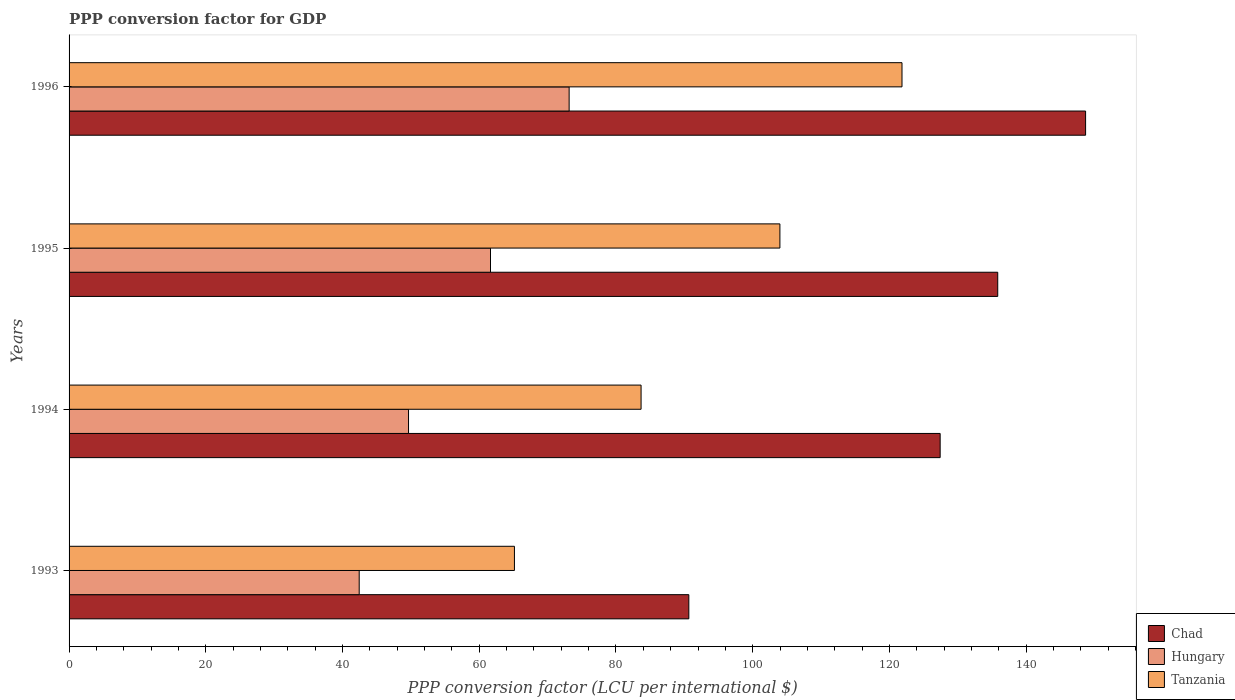How many different coloured bars are there?
Offer a very short reply. 3. How many groups of bars are there?
Ensure brevity in your answer.  4. Are the number of bars per tick equal to the number of legend labels?
Give a very brief answer. Yes. How many bars are there on the 2nd tick from the top?
Make the answer very short. 3. In how many cases, is the number of bars for a given year not equal to the number of legend labels?
Offer a terse response. 0. What is the PPP conversion factor for GDP in Hungary in 1994?
Keep it short and to the point. 49.66. Across all years, what is the maximum PPP conversion factor for GDP in Hungary?
Offer a terse response. 73.15. Across all years, what is the minimum PPP conversion factor for GDP in Hungary?
Give a very brief answer. 42.44. In which year was the PPP conversion factor for GDP in Tanzania minimum?
Provide a succinct answer. 1993. What is the total PPP conversion factor for GDP in Chad in the graph?
Offer a very short reply. 502.6. What is the difference between the PPP conversion factor for GDP in Tanzania in 1994 and that in 1996?
Provide a short and direct response. -38.16. What is the difference between the PPP conversion factor for GDP in Chad in 1994 and the PPP conversion factor for GDP in Tanzania in 1996?
Give a very brief answer. 5.58. What is the average PPP conversion factor for GDP in Chad per year?
Give a very brief answer. 125.65. In the year 1994, what is the difference between the PPP conversion factor for GDP in Hungary and PPP conversion factor for GDP in Tanzania?
Give a very brief answer. -34.02. In how many years, is the PPP conversion factor for GDP in Chad greater than 4 LCU?
Keep it short and to the point. 4. What is the ratio of the PPP conversion factor for GDP in Chad in 1994 to that in 1995?
Offer a very short reply. 0.94. Is the PPP conversion factor for GDP in Tanzania in 1994 less than that in 1995?
Your answer should be compact. Yes. Is the difference between the PPP conversion factor for GDP in Hungary in 1995 and 1996 greater than the difference between the PPP conversion factor for GDP in Tanzania in 1995 and 1996?
Provide a short and direct response. Yes. What is the difference between the highest and the second highest PPP conversion factor for GDP in Tanzania?
Offer a very short reply. 17.86. What is the difference between the highest and the lowest PPP conversion factor for GDP in Tanzania?
Make the answer very short. 56.69. In how many years, is the PPP conversion factor for GDP in Chad greater than the average PPP conversion factor for GDP in Chad taken over all years?
Ensure brevity in your answer.  3. Is the sum of the PPP conversion factor for GDP in Chad in 1995 and 1996 greater than the maximum PPP conversion factor for GDP in Tanzania across all years?
Make the answer very short. Yes. What does the 3rd bar from the top in 1993 represents?
Your response must be concise. Chad. What does the 1st bar from the bottom in 1996 represents?
Make the answer very short. Chad. Is it the case that in every year, the sum of the PPP conversion factor for GDP in Chad and PPP conversion factor for GDP in Tanzania is greater than the PPP conversion factor for GDP in Hungary?
Provide a short and direct response. Yes. How many bars are there?
Your response must be concise. 12. Are all the bars in the graph horizontal?
Provide a short and direct response. Yes. How many years are there in the graph?
Provide a succinct answer. 4. What is the difference between two consecutive major ticks on the X-axis?
Make the answer very short. 20. Does the graph contain any zero values?
Keep it short and to the point. No. Where does the legend appear in the graph?
Your answer should be compact. Bottom right. How are the legend labels stacked?
Your response must be concise. Vertical. What is the title of the graph?
Your answer should be very brief. PPP conversion factor for GDP. What is the label or title of the X-axis?
Provide a short and direct response. PPP conversion factor (LCU per international $). What is the label or title of the Y-axis?
Give a very brief answer. Years. What is the PPP conversion factor (LCU per international $) of Chad in 1993?
Your answer should be very brief. 90.65. What is the PPP conversion factor (LCU per international $) in Hungary in 1993?
Give a very brief answer. 42.44. What is the PPP conversion factor (LCU per international $) in Tanzania in 1993?
Offer a terse response. 65.15. What is the PPP conversion factor (LCU per international $) in Chad in 1994?
Offer a very short reply. 127.42. What is the PPP conversion factor (LCU per international $) of Hungary in 1994?
Make the answer very short. 49.66. What is the PPP conversion factor (LCU per international $) of Tanzania in 1994?
Offer a terse response. 83.67. What is the PPP conversion factor (LCU per international $) of Chad in 1995?
Offer a terse response. 135.84. What is the PPP conversion factor (LCU per international $) of Hungary in 1995?
Provide a succinct answer. 61.64. What is the PPP conversion factor (LCU per international $) of Tanzania in 1995?
Ensure brevity in your answer.  103.98. What is the PPP conversion factor (LCU per international $) in Chad in 1996?
Give a very brief answer. 148.69. What is the PPP conversion factor (LCU per international $) in Hungary in 1996?
Offer a terse response. 73.15. What is the PPP conversion factor (LCU per international $) in Tanzania in 1996?
Your response must be concise. 121.84. Across all years, what is the maximum PPP conversion factor (LCU per international $) in Chad?
Offer a very short reply. 148.69. Across all years, what is the maximum PPP conversion factor (LCU per international $) of Hungary?
Give a very brief answer. 73.15. Across all years, what is the maximum PPP conversion factor (LCU per international $) in Tanzania?
Your answer should be very brief. 121.84. Across all years, what is the minimum PPP conversion factor (LCU per international $) of Chad?
Offer a terse response. 90.65. Across all years, what is the minimum PPP conversion factor (LCU per international $) in Hungary?
Offer a very short reply. 42.44. Across all years, what is the minimum PPP conversion factor (LCU per international $) in Tanzania?
Your answer should be compact. 65.15. What is the total PPP conversion factor (LCU per international $) of Chad in the graph?
Your response must be concise. 502.6. What is the total PPP conversion factor (LCU per international $) in Hungary in the graph?
Your answer should be compact. 226.89. What is the total PPP conversion factor (LCU per international $) in Tanzania in the graph?
Your response must be concise. 374.63. What is the difference between the PPP conversion factor (LCU per international $) in Chad in 1993 and that in 1994?
Make the answer very short. -36.76. What is the difference between the PPP conversion factor (LCU per international $) in Hungary in 1993 and that in 1994?
Provide a succinct answer. -7.22. What is the difference between the PPP conversion factor (LCU per international $) of Tanzania in 1993 and that in 1994?
Your answer should be very brief. -18.53. What is the difference between the PPP conversion factor (LCU per international $) in Chad in 1993 and that in 1995?
Your answer should be very brief. -45.19. What is the difference between the PPP conversion factor (LCU per international $) in Hungary in 1993 and that in 1995?
Make the answer very short. -19.2. What is the difference between the PPP conversion factor (LCU per international $) of Tanzania in 1993 and that in 1995?
Offer a terse response. -38.83. What is the difference between the PPP conversion factor (LCU per international $) in Chad in 1993 and that in 1996?
Give a very brief answer. -58.04. What is the difference between the PPP conversion factor (LCU per international $) of Hungary in 1993 and that in 1996?
Keep it short and to the point. -30.71. What is the difference between the PPP conversion factor (LCU per international $) of Tanzania in 1993 and that in 1996?
Provide a short and direct response. -56.69. What is the difference between the PPP conversion factor (LCU per international $) in Chad in 1994 and that in 1995?
Provide a succinct answer. -8.42. What is the difference between the PPP conversion factor (LCU per international $) in Hungary in 1994 and that in 1995?
Your answer should be very brief. -11.99. What is the difference between the PPP conversion factor (LCU per international $) in Tanzania in 1994 and that in 1995?
Your answer should be very brief. -20.31. What is the difference between the PPP conversion factor (LCU per international $) in Chad in 1994 and that in 1996?
Your answer should be very brief. -21.27. What is the difference between the PPP conversion factor (LCU per international $) of Hungary in 1994 and that in 1996?
Provide a short and direct response. -23.49. What is the difference between the PPP conversion factor (LCU per international $) in Tanzania in 1994 and that in 1996?
Keep it short and to the point. -38.16. What is the difference between the PPP conversion factor (LCU per international $) of Chad in 1995 and that in 1996?
Offer a terse response. -12.85. What is the difference between the PPP conversion factor (LCU per international $) in Hungary in 1995 and that in 1996?
Make the answer very short. -11.5. What is the difference between the PPP conversion factor (LCU per international $) of Tanzania in 1995 and that in 1996?
Provide a succinct answer. -17.86. What is the difference between the PPP conversion factor (LCU per international $) in Chad in 1993 and the PPP conversion factor (LCU per international $) in Hungary in 1994?
Your answer should be very brief. 41. What is the difference between the PPP conversion factor (LCU per international $) in Chad in 1993 and the PPP conversion factor (LCU per international $) in Tanzania in 1994?
Provide a succinct answer. 6.98. What is the difference between the PPP conversion factor (LCU per international $) in Hungary in 1993 and the PPP conversion factor (LCU per international $) in Tanzania in 1994?
Keep it short and to the point. -41.23. What is the difference between the PPP conversion factor (LCU per international $) in Chad in 1993 and the PPP conversion factor (LCU per international $) in Hungary in 1995?
Ensure brevity in your answer.  29.01. What is the difference between the PPP conversion factor (LCU per international $) of Chad in 1993 and the PPP conversion factor (LCU per international $) of Tanzania in 1995?
Your answer should be compact. -13.32. What is the difference between the PPP conversion factor (LCU per international $) in Hungary in 1993 and the PPP conversion factor (LCU per international $) in Tanzania in 1995?
Give a very brief answer. -61.54. What is the difference between the PPP conversion factor (LCU per international $) of Chad in 1993 and the PPP conversion factor (LCU per international $) of Hungary in 1996?
Ensure brevity in your answer.  17.51. What is the difference between the PPP conversion factor (LCU per international $) of Chad in 1993 and the PPP conversion factor (LCU per international $) of Tanzania in 1996?
Your answer should be compact. -31.18. What is the difference between the PPP conversion factor (LCU per international $) of Hungary in 1993 and the PPP conversion factor (LCU per international $) of Tanzania in 1996?
Provide a succinct answer. -79.4. What is the difference between the PPP conversion factor (LCU per international $) of Chad in 1994 and the PPP conversion factor (LCU per international $) of Hungary in 1995?
Your answer should be very brief. 65.77. What is the difference between the PPP conversion factor (LCU per international $) of Chad in 1994 and the PPP conversion factor (LCU per international $) of Tanzania in 1995?
Ensure brevity in your answer.  23.44. What is the difference between the PPP conversion factor (LCU per international $) of Hungary in 1994 and the PPP conversion factor (LCU per international $) of Tanzania in 1995?
Give a very brief answer. -54.32. What is the difference between the PPP conversion factor (LCU per international $) of Chad in 1994 and the PPP conversion factor (LCU per international $) of Hungary in 1996?
Ensure brevity in your answer.  54.27. What is the difference between the PPP conversion factor (LCU per international $) of Chad in 1994 and the PPP conversion factor (LCU per international $) of Tanzania in 1996?
Offer a very short reply. 5.58. What is the difference between the PPP conversion factor (LCU per international $) in Hungary in 1994 and the PPP conversion factor (LCU per international $) in Tanzania in 1996?
Provide a short and direct response. -72.18. What is the difference between the PPP conversion factor (LCU per international $) in Chad in 1995 and the PPP conversion factor (LCU per international $) in Hungary in 1996?
Offer a terse response. 62.69. What is the difference between the PPP conversion factor (LCU per international $) in Chad in 1995 and the PPP conversion factor (LCU per international $) in Tanzania in 1996?
Provide a short and direct response. 14. What is the difference between the PPP conversion factor (LCU per international $) in Hungary in 1995 and the PPP conversion factor (LCU per international $) in Tanzania in 1996?
Your response must be concise. -60.19. What is the average PPP conversion factor (LCU per international $) of Chad per year?
Make the answer very short. 125.65. What is the average PPP conversion factor (LCU per international $) of Hungary per year?
Your answer should be compact. 56.72. What is the average PPP conversion factor (LCU per international $) of Tanzania per year?
Provide a succinct answer. 93.66. In the year 1993, what is the difference between the PPP conversion factor (LCU per international $) of Chad and PPP conversion factor (LCU per international $) of Hungary?
Offer a very short reply. 48.21. In the year 1993, what is the difference between the PPP conversion factor (LCU per international $) in Chad and PPP conversion factor (LCU per international $) in Tanzania?
Ensure brevity in your answer.  25.51. In the year 1993, what is the difference between the PPP conversion factor (LCU per international $) of Hungary and PPP conversion factor (LCU per international $) of Tanzania?
Provide a short and direct response. -22.71. In the year 1994, what is the difference between the PPP conversion factor (LCU per international $) in Chad and PPP conversion factor (LCU per international $) in Hungary?
Your response must be concise. 77.76. In the year 1994, what is the difference between the PPP conversion factor (LCU per international $) in Chad and PPP conversion factor (LCU per international $) in Tanzania?
Give a very brief answer. 43.75. In the year 1994, what is the difference between the PPP conversion factor (LCU per international $) in Hungary and PPP conversion factor (LCU per international $) in Tanzania?
Ensure brevity in your answer.  -34.02. In the year 1995, what is the difference between the PPP conversion factor (LCU per international $) of Chad and PPP conversion factor (LCU per international $) of Hungary?
Your answer should be very brief. 74.2. In the year 1995, what is the difference between the PPP conversion factor (LCU per international $) of Chad and PPP conversion factor (LCU per international $) of Tanzania?
Your answer should be very brief. 31.86. In the year 1995, what is the difference between the PPP conversion factor (LCU per international $) of Hungary and PPP conversion factor (LCU per international $) of Tanzania?
Provide a short and direct response. -42.33. In the year 1996, what is the difference between the PPP conversion factor (LCU per international $) of Chad and PPP conversion factor (LCU per international $) of Hungary?
Your answer should be very brief. 75.54. In the year 1996, what is the difference between the PPP conversion factor (LCU per international $) in Chad and PPP conversion factor (LCU per international $) in Tanzania?
Offer a terse response. 26.86. In the year 1996, what is the difference between the PPP conversion factor (LCU per international $) in Hungary and PPP conversion factor (LCU per international $) in Tanzania?
Give a very brief answer. -48.69. What is the ratio of the PPP conversion factor (LCU per international $) in Chad in 1993 to that in 1994?
Provide a succinct answer. 0.71. What is the ratio of the PPP conversion factor (LCU per international $) in Hungary in 1993 to that in 1994?
Give a very brief answer. 0.85. What is the ratio of the PPP conversion factor (LCU per international $) of Tanzania in 1993 to that in 1994?
Offer a terse response. 0.78. What is the ratio of the PPP conversion factor (LCU per international $) in Chad in 1993 to that in 1995?
Your answer should be compact. 0.67. What is the ratio of the PPP conversion factor (LCU per international $) in Hungary in 1993 to that in 1995?
Your response must be concise. 0.69. What is the ratio of the PPP conversion factor (LCU per international $) in Tanzania in 1993 to that in 1995?
Your response must be concise. 0.63. What is the ratio of the PPP conversion factor (LCU per international $) in Chad in 1993 to that in 1996?
Your answer should be compact. 0.61. What is the ratio of the PPP conversion factor (LCU per international $) in Hungary in 1993 to that in 1996?
Give a very brief answer. 0.58. What is the ratio of the PPP conversion factor (LCU per international $) in Tanzania in 1993 to that in 1996?
Your answer should be compact. 0.53. What is the ratio of the PPP conversion factor (LCU per international $) in Chad in 1994 to that in 1995?
Your response must be concise. 0.94. What is the ratio of the PPP conversion factor (LCU per international $) of Hungary in 1994 to that in 1995?
Keep it short and to the point. 0.81. What is the ratio of the PPP conversion factor (LCU per international $) of Tanzania in 1994 to that in 1995?
Your answer should be very brief. 0.8. What is the ratio of the PPP conversion factor (LCU per international $) in Chad in 1994 to that in 1996?
Offer a very short reply. 0.86. What is the ratio of the PPP conversion factor (LCU per international $) in Hungary in 1994 to that in 1996?
Make the answer very short. 0.68. What is the ratio of the PPP conversion factor (LCU per international $) in Tanzania in 1994 to that in 1996?
Your response must be concise. 0.69. What is the ratio of the PPP conversion factor (LCU per international $) of Chad in 1995 to that in 1996?
Offer a very short reply. 0.91. What is the ratio of the PPP conversion factor (LCU per international $) in Hungary in 1995 to that in 1996?
Your response must be concise. 0.84. What is the ratio of the PPP conversion factor (LCU per international $) of Tanzania in 1995 to that in 1996?
Keep it short and to the point. 0.85. What is the difference between the highest and the second highest PPP conversion factor (LCU per international $) in Chad?
Offer a very short reply. 12.85. What is the difference between the highest and the second highest PPP conversion factor (LCU per international $) of Hungary?
Provide a short and direct response. 11.5. What is the difference between the highest and the second highest PPP conversion factor (LCU per international $) of Tanzania?
Keep it short and to the point. 17.86. What is the difference between the highest and the lowest PPP conversion factor (LCU per international $) of Chad?
Offer a very short reply. 58.04. What is the difference between the highest and the lowest PPP conversion factor (LCU per international $) in Hungary?
Provide a succinct answer. 30.71. What is the difference between the highest and the lowest PPP conversion factor (LCU per international $) in Tanzania?
Ensure brevity in your answer.  56.69. 